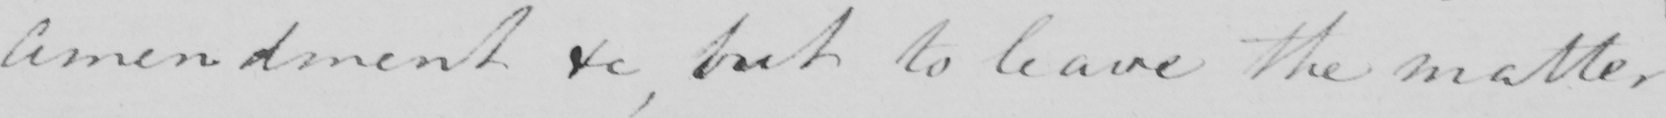What does this handwritten line say? amendment &c , but to leave the matter 